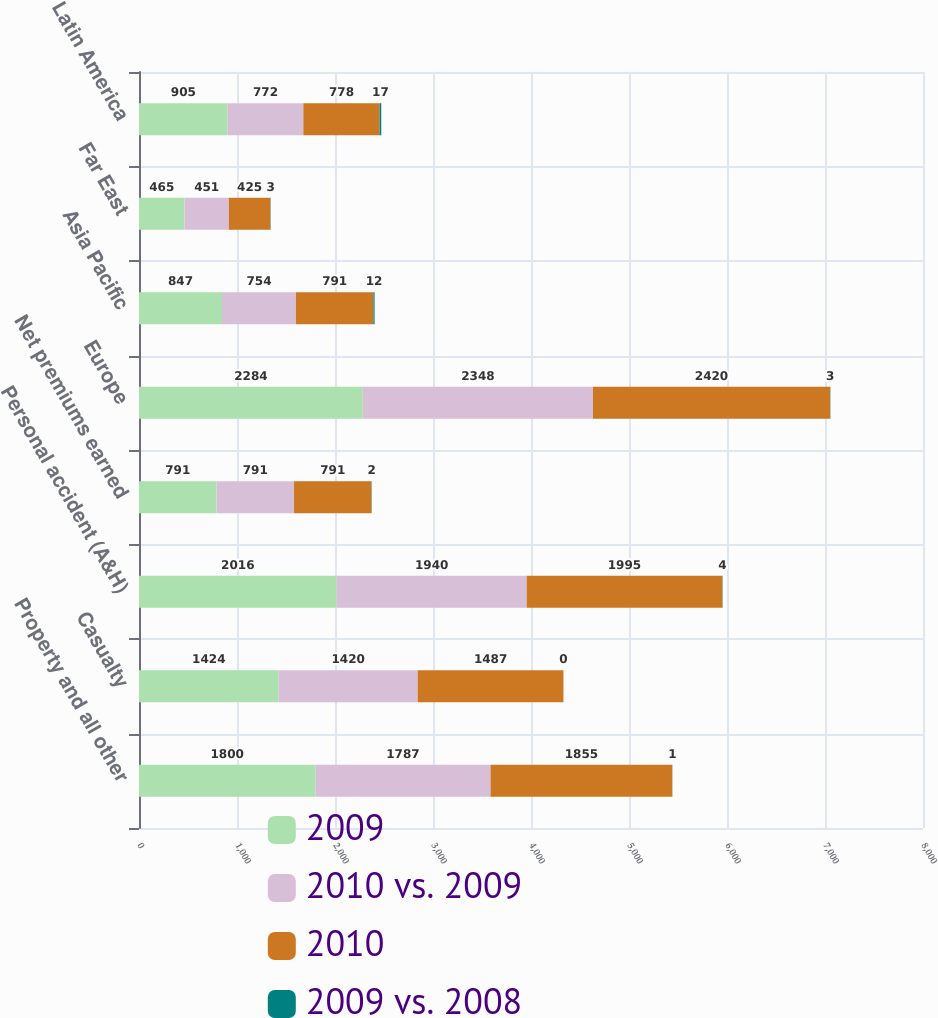<chart> <loc_0><loc_0><loc_500><loc_500><stacked_bar_chart><ecel><fcel>Property and all other<fcel>Casualty<fcel>Personal accident (A&H)<fcel>Net premiums earned<fcel>Europe<fcel>Asia Pacific<fcel>Far East<fcel>Latin America<nl><fcel>2009<fcel>1800<fcel>1424<fcel>2016<fcel>791<fcel>2284<fcel>847<fcel>465<fcel>905<nl><fcel>2010 vs. 2009<fcel>1787<fcel>1420<fcel>1940<fcel>791<fcel>2348<fcel>754<fcel>451<fcel>772<nl><fcel>2010<fcel>1855<fcel>1487<fcel>1995<fcel>791<fcel>2420<fcel>791<fcel>425<fcel>778<nl><fcel>2009 vs. 2008<fcel>1<fcel>0<fcel>4<fcel>2<fcel>3<fcel>12<fcel>3<fcel>17<nl></chart> 